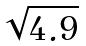Convert formula to latex. <formula><loc_0><loc_0><loc_500><loc_500>\sqrt { 4 . 9 }</formula> 